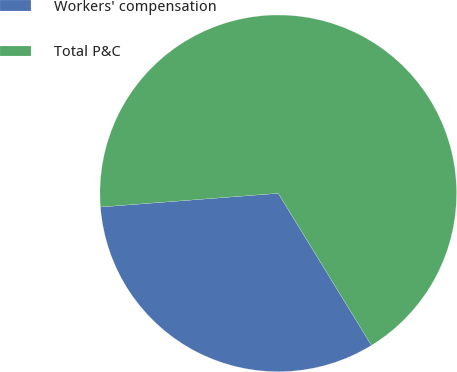Convert chart to OTSL. <chart><loc_0><loc_0><loc_500><loc_500><pie_chart><fcel>Workers' compensation<fcel>Total P&C<nl><fcel>32.53%<fcel>67.47%<nl></chart> 